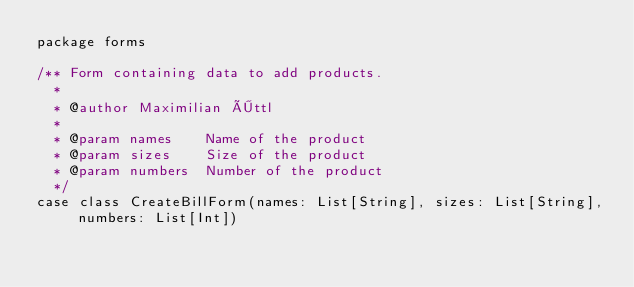Convert code to text. <code><loc_0><loc_0><loc_500><loc_500><_Scala_>package forms

/** Form containing data to add products.
  *
  * @author Maximilian Öttl
  *
  * @param names    Name of the product
  * @param sizes    Size of the product
  * @param numbers  Number of the product
  */
case class CreateBillForm(names: List[String], sizes: List[String], numbers: List[Int])</code> 